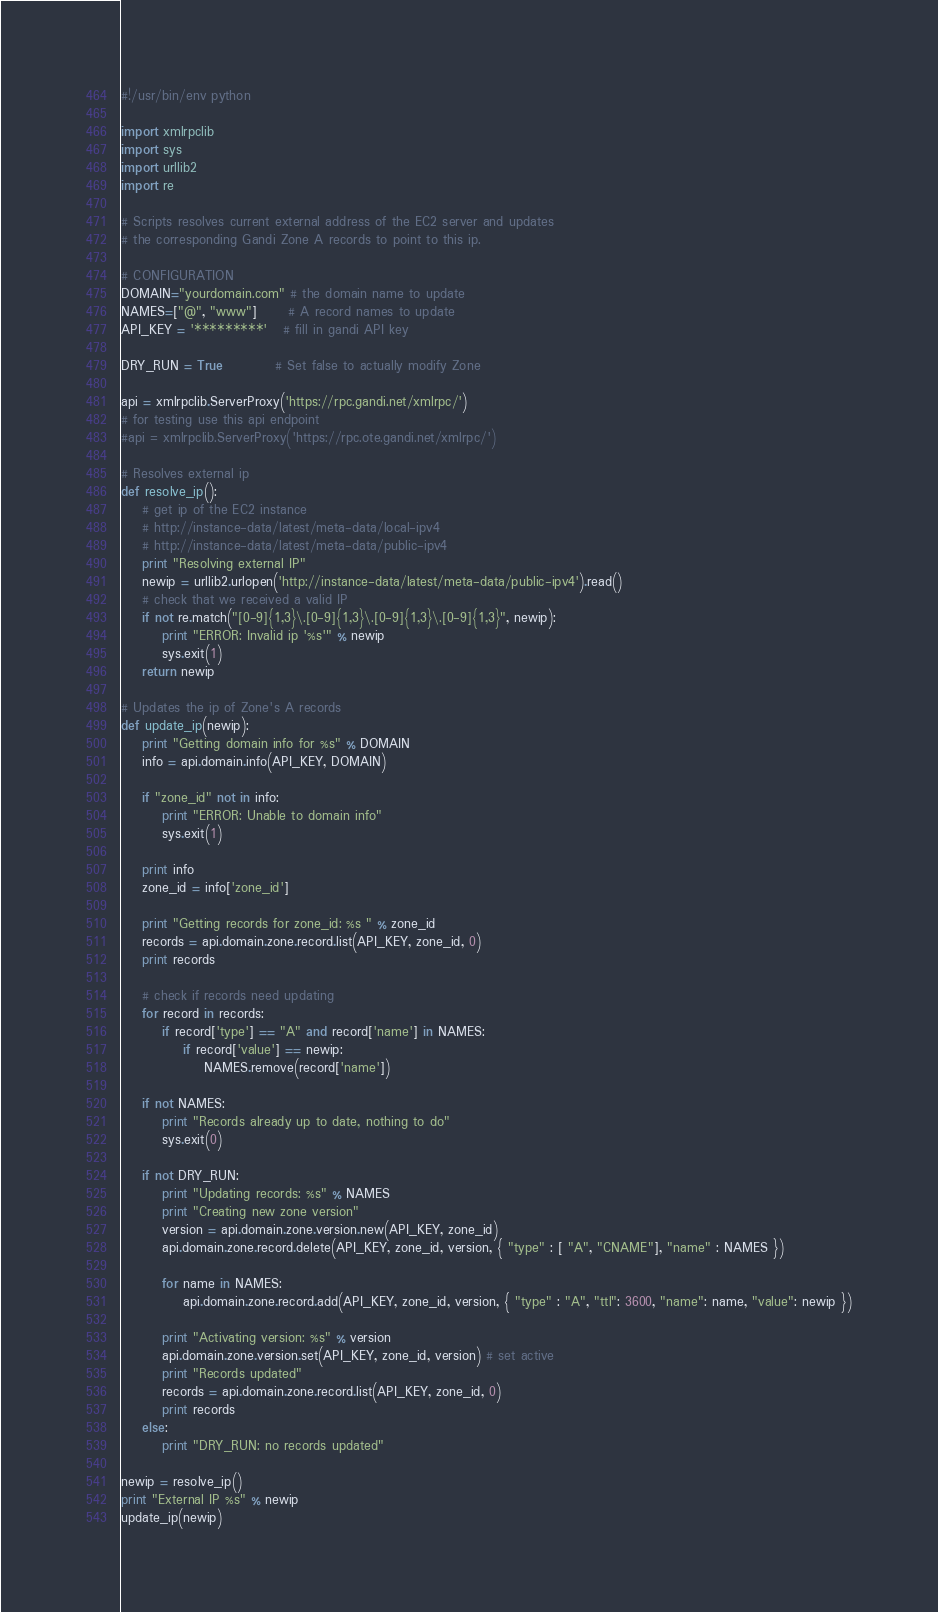<code> <loc_0><loc_0><loc_500><loc_500><_Python_>#!/usr/bin/env python

import xmlrpclib
import sys
import urllib2
import re

# Scripts resolves current external address of the EC2 server and updates
# the corresponding Gandi Zone A records to point to this ip.

# CONFIGURATION
DOMAIN="yourdomain.com" # the domain name to update
NAMES=["@", "www"]      # A record names to update
API_KEY = '*********'   # fill in gandi API key

DRY_RUN = True          # Set false to actually modify Zone

api = xmlrpclib.ServerProxy('https://rpc.gandi.net/xmlrpc/')
# for testing use this api endpoint
#api = xmlrpclib.ServerProxy('https://rpc.ote.gandi.net/xmlrpc/')

# Resolves external ip
def resolve_ip():
	# get ip of the EC2 instance
	# http://instance-data/latest/meta-data/local-ipv4
	# http://instance-data/latest/meta-data/public-ipv4
	print "Resolving external IP"
	newip = urllib2.urlopen('http://instance-data/latest/meta-data/public-ipv4').read()
	# check that we received a valid IP
	if not re.match("[0-9]{1,3}\.[0-9]{1,3}\.[0-9]{1,3}\.[0-9]{1,3}", newip):
		print "ERROR: Invalid ip '%s'" % newip
		sys.exit(1)
	return newip

# Updates the ip of Zone's A records
def update_ip(newip):
	print "Getting domain info for %s" % DOMAIN
	info = api.domain.info(API_KEY, DOMAIN)

	if "zone_id" not in info:
		print "ERROR: Unable to domain info"
		sys.exit(1)

	print info
	zone_id = info['zone_id']

	print "Getting records for zone_id: %s " % zone_id
	records = api.domain.zone.record.list(API_KEY, zone_id, 0)
	print records

	# check if records need updating
	for record in records:
		if record['type'] == "A" and record['name'] in NAMES:
			if record['value'] == newip:
				NAMES.remove(record['name'])

	if not NAMES:
		print "Records already up to date, nothing to do"
		sys.exit(0)

	if not DRY_RUN:
		print "Updating records: %s" % NAMES
		print "Creating new zone version"
		version = api.domain.zone.version.new(API_KEY, zone_id)
		api.domain.zone.record.delete(API_KEY, zone_id, version, { "type" : [ "A", "CNAME"], "name" : NAMES })
		
		for name in NAMES:
			api.domain.zone.record.add(API_KEY, zone_id, version, { "type" : "A", "ttl": 3600, "name": name, "value": newip })
		
		print "Activating version: %s" % version
		api.domain.zone.version.set(API_KEY, zone_id, version) # set active
		print "Records updated"
		records = api.domain.zone.record.list(API_KEY, zone_id, 0)
		print records
	else:
		print "DRY_RUN: no records updated"

newip = resolve_ip()
print "External IP %s" % newip
update_ip(newip)




</code> 